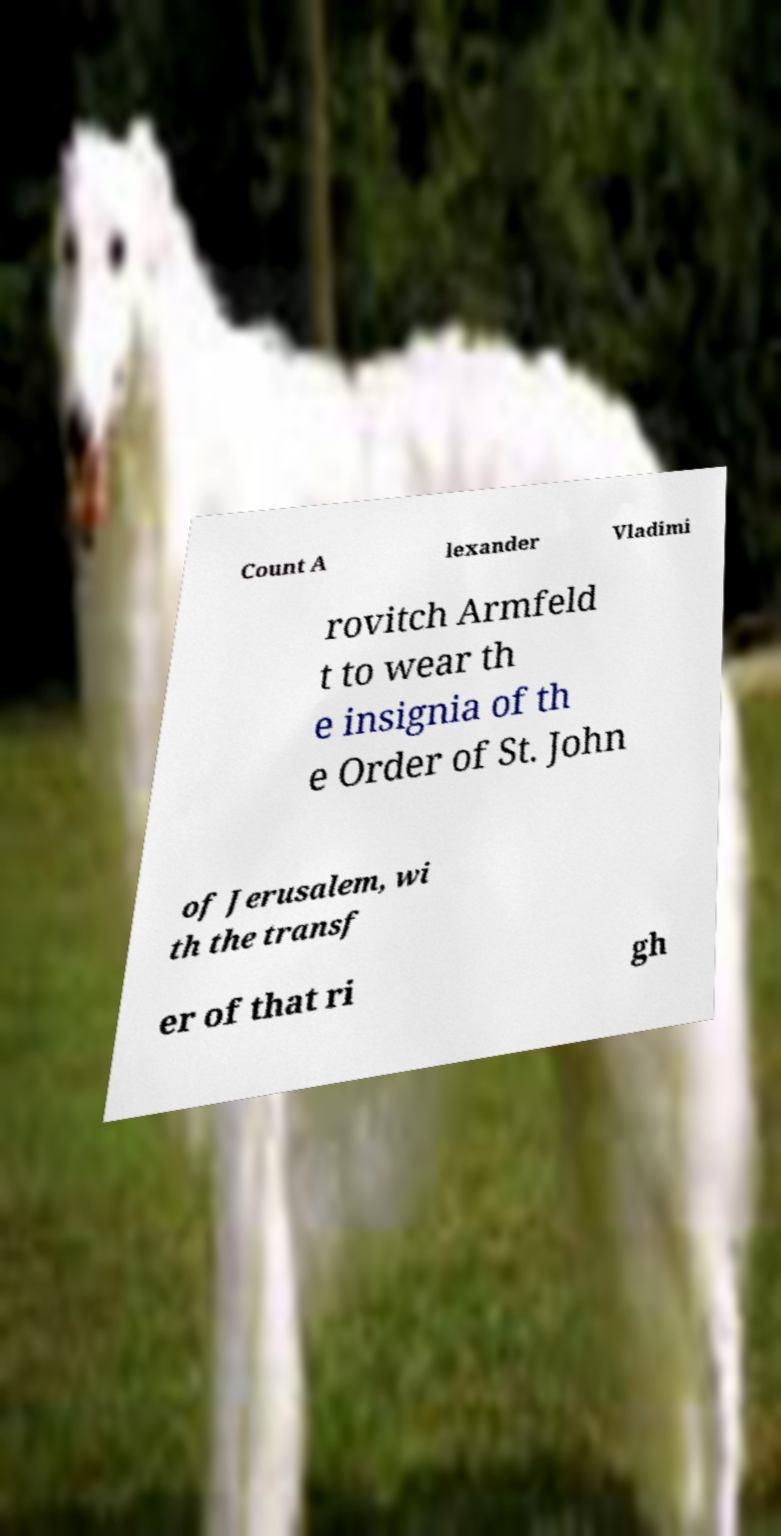Can you read and provide the text displayed in the image?This photo seems to have some interesting text. Can you extract and type it out for me? Count A lexander Vladimi rovitch Armfeld t to wear th e insignia of th e Order of St. John of Jerusalem, wi th the transf er of that ri gh 